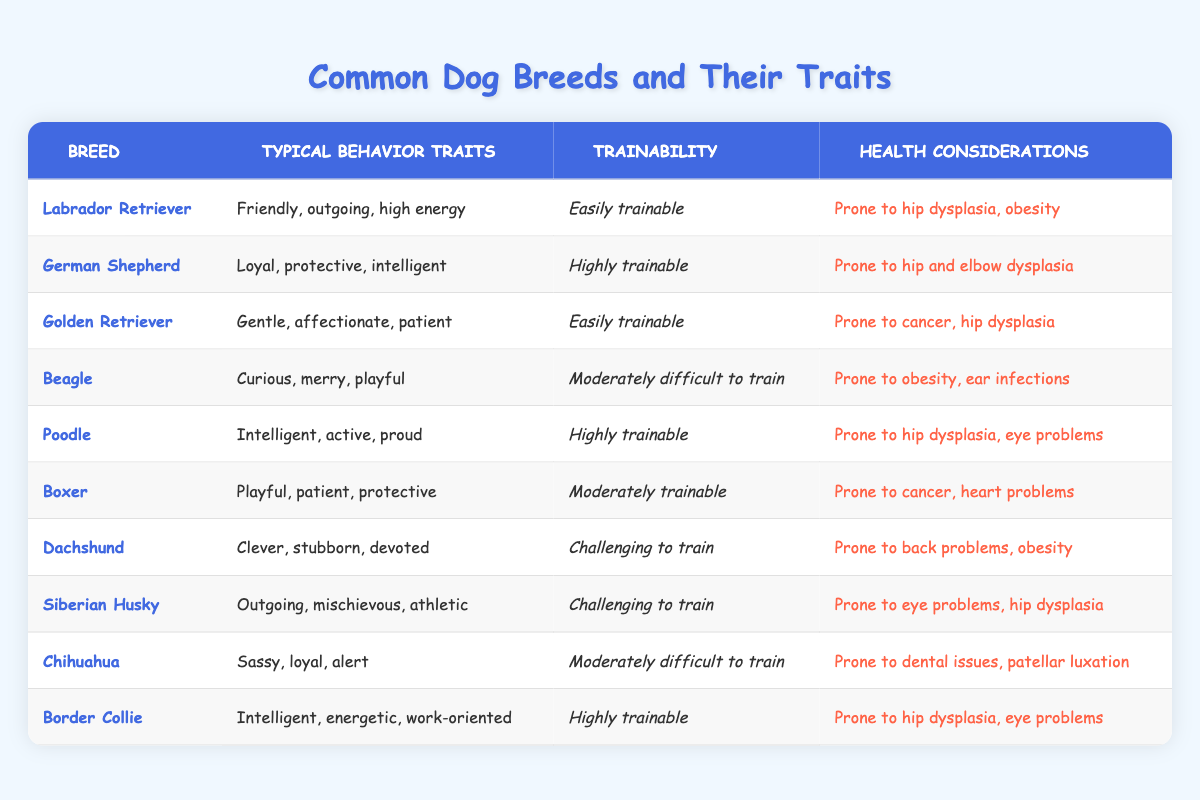What are the typical behavior traits of a German Shepherd? The table lists "Loyal, protective, intelligent" as the typical behavior traits of a German Shepherd.
Answer: Loyal, protective, intelligent Which dog breed is considered easily trainable? According to the table, both Labrador Retrievers and Golden Retrievers are classified as easily trainable, along with Poodles and Border Collies.
Answer: Labrador Retriever, Golden Retriever, Poodle, Border Collie What is the most common health consideration for many dog breeds listed? The health consideration "hip dysplasia" appears for Labrador Retrievers, German Shepherds, Poodles, and Border Collies, indicating that it is a common health issue for multiple breeds.
Answer: Hip dysplasia Which dog breed has a playful and patient temperament? The table indicates that the Boxer breed is described as playful and patient in its typical behavior traits.
Answer: Boxer Do Beagles have high or low trainability? The table states that Beagles are "moderately difficult to train," indicating their trainability is not high.
Answer: Moderately difficult to train How many dog breeds listed are classified as having a "highly trainable" trait? The table shows that three breeds (German Shepherd, Poodle, and Border Collie) are classified as highly trainable. So, there are three breeds.
Answer: Three Is the Siberian Husky prone to heart problems? The table indicates that Siberian Huskies are prone to eye problems and hip dysplasia but does not list heart problems, so the answer is no.
Answer: No Which breed is described as "outgoing, mischievous, athletic"? The table specifies that the Siberian Husky is described with these traits, confirming its playful yet adventurous personality.
Answer: Siberian Husky What breed has a health consideration of cancer? The table mentions that both Boxers and Golden Retrievers have cancer listed as a health consideration, showing that it affects those two breeds.
Answer: Boxer, Golden Retriever 